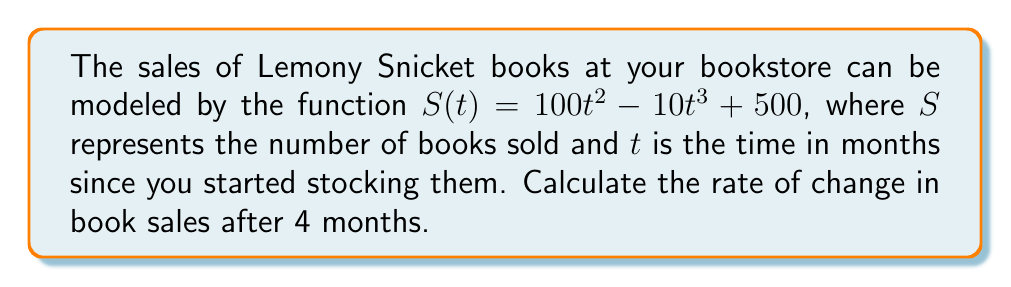Show me your answer to this math problem. To find the rate of change in book sales after 4 months, we need to calculate the derivative of the sales function $S(t)$ and then evaluate it at $t = 4$.

1. Let's start by finding the derivative of $S(t)$:

   $S(t) = 100t^2 - 10t^3 + 500$
   
   $\frac{d}{dt}S(t) = \frac{d}{dt}(100t^2) - \frac{d}{dt}(10t^3) + \frac{d}{dt}(500)$
   
   $S'(t) = 200t - 30t^2 + 0$
   
   $S'(t) = 200t - 30t^2$

2. Now that we have the derivative, which represents the rate of change of book sales at any given time, we can evaluate it at $t = 4$:

   $S'(4) = 200(4) - 30(4)^2$
   
   $S'(4) = 800 - 30(16)$
   
   $S'(4) = 800 - 480$
   
   $S'(4) = 320$

3. The units for this rate of change would be books per month, as $t$ is measured in months.

Therefore, after 4 months, the rate of change in Lemony Snicket book sales is 320 books per month.
Answer: 320 books per month 